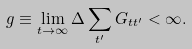<formula> <loc_0><loc_0><loc_500><loc_500>g \equiv \lim _ { t \rightarrow \infty } \Delta \sum _ { t ^ { \prime } } G _ { t t ^ { \prime } } < \infty .</formula> 